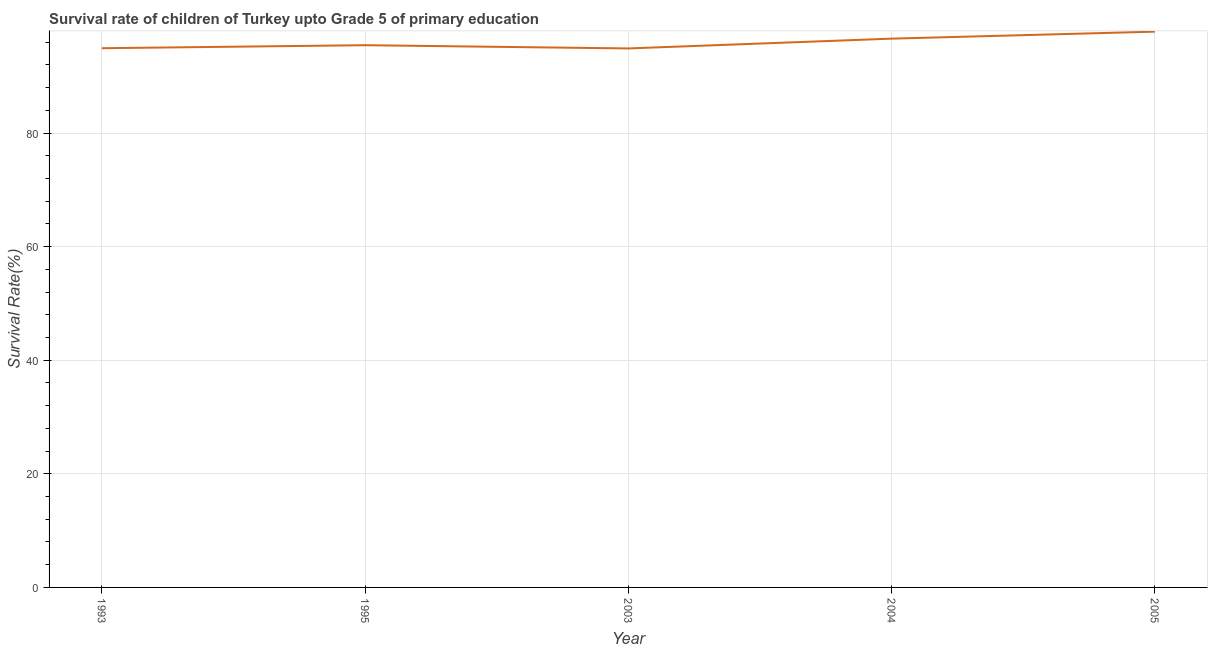What is the survival rate in 2005?
Make the answer very short. 97.84. Across all years, what is the maximum survival rate?
Your answer should be compact. 97.84. Across all years, what is the minimum survival rate?
Provide a short and direct response. 94.89. In which year was the survival rate minimum?
Offer a very short reply. 2003. What is the sum of the survival rate?
Offer a very short reply. 479.73. What is the difference between the survival rate in 2004 and 2005?
Keep it short and to the point. -1.23. What is the average survival rate per year?
Your response must be concise. 95.95. What is the median survival rate?
Your answer should be compact. 95.46. What is the ratio of the survival rate in 1993 to that in 1995?
Offer a very short reply. 0.99. Is the survival rate in 1993 less than that in 2004?
Your answer should be very brief. Yes. Is the difference between the survival rate in 2004 and 2005 greater than the difference between any two years?
Ensure brevity in your answer.  No. What is the difference between the highest and the second highest survival rate?
Your response must be concise. 1.23. Is the sum of the survival rate in 1995 and 2004 greater than the maximum survival rate across all years?
Offer a terse response. Yes. What is the difference between the highest and the lowest survival rate?
Ensure brevity in your answer.  2.95. In how many years, is the survival rate greater than the average survival rate taken over all years?
Ensure brevity in your answer.  2. How many years are there in the graph?
Your response must be concise. 5. Does the graph contain any zero values?
Provide a short and direct response. No. What is the title of the graph?
Your answer should be very brief. Survival rate of children of Turkey upto Grade 5 of primary education. What is the label or title of the X-axis?
Offer a terse response. Year. What is the label or title of the Y-axis?
Your answer should be compact. Survival Rate(%). What is the Survival Rate(%) of 1993?
Make the answer very short. 94.93. What is the Survival Rate(%) of 1995?
Give a very brief answer. 95.46. What is the Survival Rate(%) in 2003?
Ensure brevity in your answer.  94.89. What is the Survival Rate(%) of 2004?
Your answer should be compact. 96.61. What is the Survival Rate(%) of 2005?
Ensure brevity in your answer.  97.84. What is the difference between the Survival Rate(%) in 1993 and 1995?
Provide a succinct answer. -0.53. What is the difference between the Survival Rate(%) in 1993 and 2003?
Give a very brief answer. 0.04. What is the difference between the Survival Rate(%) in 1993 and 2004?
Your response must be concise. -1.69. What is the difference between the Survival Rate(%) in 1993 and 2005?
Offer a very short reply. -2.91. What is the difference between the Survival Rate(%) in 1995 and 2003?
Provide a succinct answer. 0.57. What is the difference between the Survival Rate(%) in 1995 and 2004?
Your answer should be compact. -1.15. What is the difference between the Survival Rate(%) in 1995 and 2005?
Offer a terse response. -2.38. What is the difference between the Survival Rate(%) in 2003 and 2004?
Your answer should be very brief. -1.72. What is the difference between the Survival Rate(%) in 2003 and 2005?
Your answer should be compact. -2.95. What is the difference between the Survival Rate(%) in 2004 and 2005?
Keep it short and to the point. -1.23. What is the ratio of the Survival Rate(%) in 1993 to that in 1995?
Offer a very short reply. 0.99. What is the ratio of the Survival Rate(%) in 1993 to that in 2003?
Provide a succinct answer. 1. What is the ratio of the Survival Rate(%) in 1993 to that in 2004?
Offer a very short reply. 0.98. What is the ratio of the Survival Rate(%) in 1995 to that in 2003?
Your answer should be compact. 1.01. What is the ratio of the Survival Rate(%) in 2003 to that in 2004?
Offer a very short reply. 0.98. What is the ratio of the Survival Rate(%) in 2003 to that in 2005?
Keep it short and to the point. 0.97. What is the ratio of the Survival Rate(%) in 2004 to that in 2005?
Make the answer very short. 0.99. 